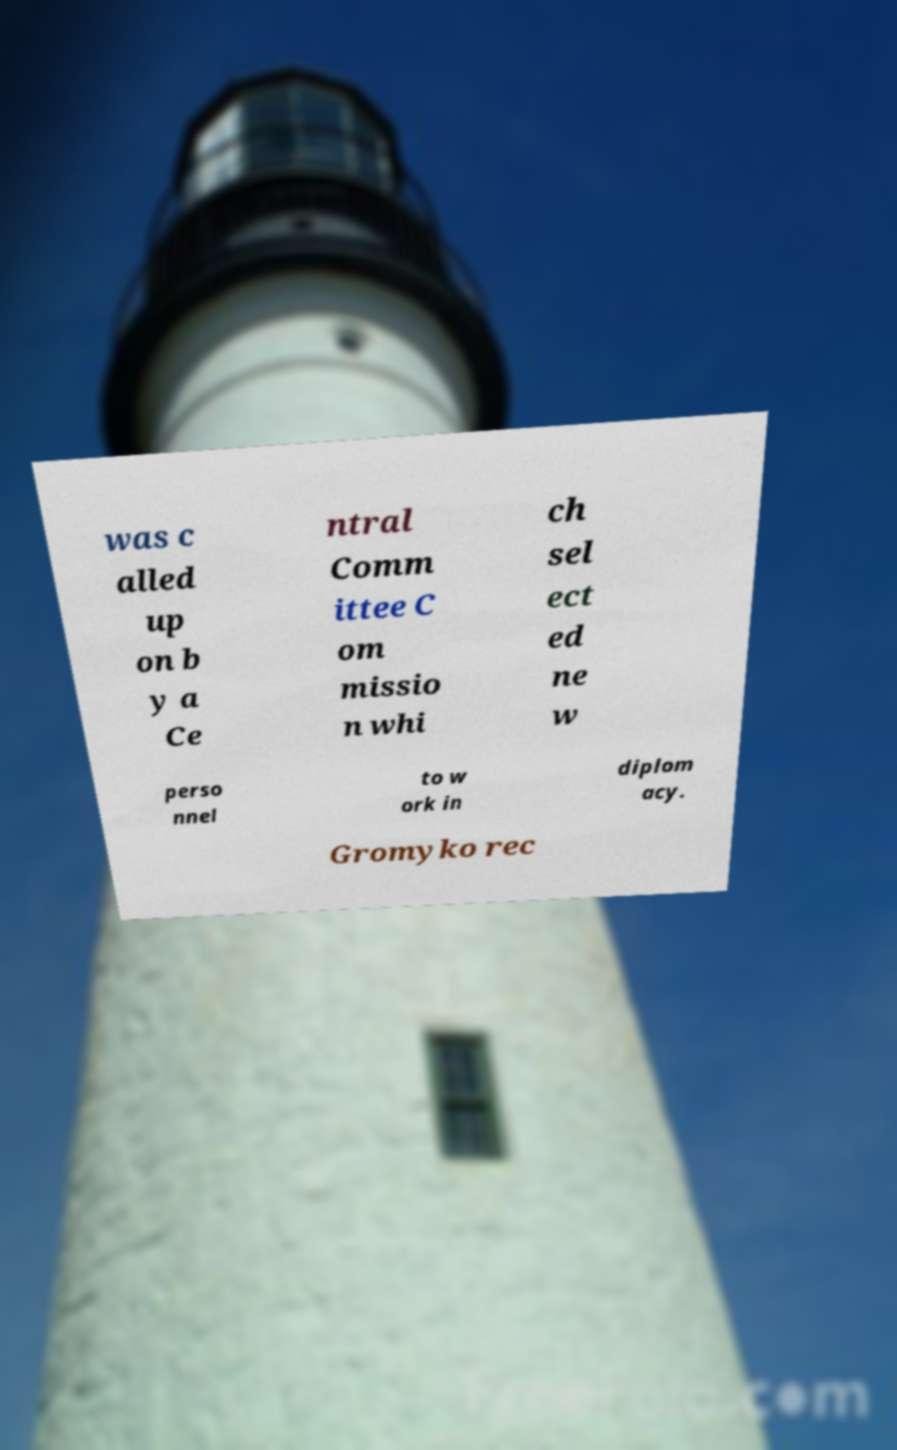Please identify and transcribe the text found in this image. was c alled up on b y a Ce ntral Comm ittee C om missio n whi ch sel ect ed ne w perso nnel to w ork in diplom acy. Gromyko rec 